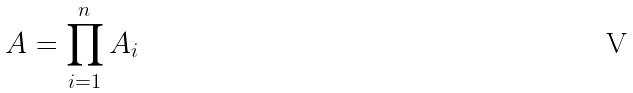Convert formula to latex. <formula><loc_0><loc_0><loc_500><loc_500>A = \prod _ { i = 1 } ^ { n } A _ { i }</formula> 